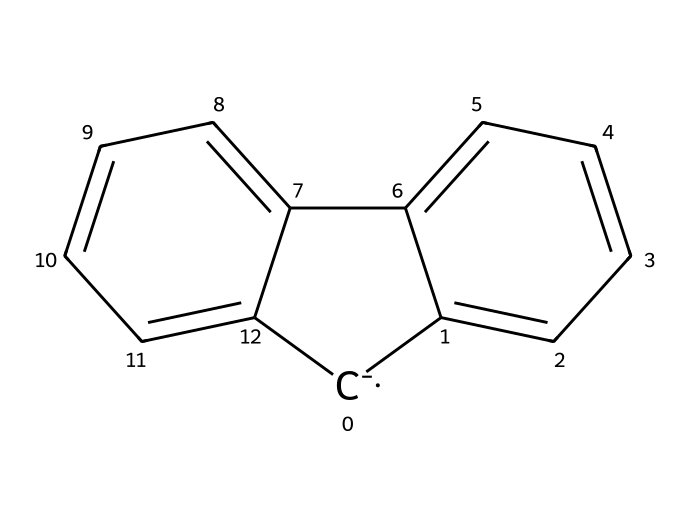How many carbon atoms are in the fluorenyl anion? The SMILES notation reveals a total of 13 carbon atoms represented in the structure. Each 'C' denotes a carbon atom in the skeletal representation.
Answer: 13 What is the overall charge of the fluorenyl anion? The presence of the '[C-]' in the SMILES notation indicates that the compound has a negatively charged carbon, which signifies that the fluorenyl anion carries a charge of -1.
Answer: -1 Is the fluorenyl anion aromatic? The structure shows a conjugated system with alternating double bonds among the carbons, fulfilling the criteria for aromaticity (cyclic, planar, and follows Huckel's rule). Therefore, it is aromatic.
Answer: aromatic How many benzene rings are fused in the fluorenyl anion structure? The visual arrangement and connection of the carbon atoms show that there are two benzene rings fused together in the fluorenyl anion.
Answer: 2 What type of chemical compound is a fluorenyl anion classified as? Based on its structure, the fluorenyl anion is a type of superbase because it contains a negatively charged carbon, which can readily accept protons, indicative of its strong basic properties.
Answer: superbase What is the significance of the negative charge in the fluorenyl anion? The negative charge makes the fluorenyl anion highly reactive, particularly with protons, allowing it to be a strong base and facilitating various chemical reactions, especially in glow-in-the-dark applications.
Answer: high reactivity 